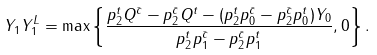Convert formula to latex. <formula><loc_0><loc_0><loc_500><loc_500>Y _ { 1 } Y ^ { L } _ { 1 } = \max \left \{ \frac { p ^ { t } _ { 2 } Q ^ { \bar { c } } - p ^ { \bar { c } } _ { 2 } Q ^ { t } - ( p ^ { t } _ { 2 } p ^ { \bar { c } } _ { 0 } - p ^ { \bar { c } } _ { 2 } p ^ { t } _ { 0 } ) Y _ { 0 } } { p ^ { t } _ { 2 } p ^ { \bar { c } } _ { 1 } - p ^ { \bar { c } } _ { 2 } p ^ { t } _ { 1 } } , 0 \right \} .</formula> 